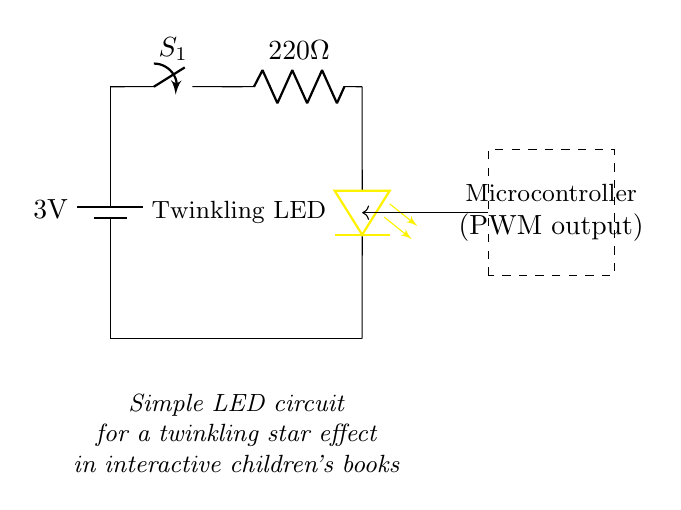What is the voltage of the battery? The voltage of the battery is labeled as 3 volts in the circuit diagram. This is a direct indication found in the schematic representation of the battery.
Answer: 3 volts What type of LED is used in the circuit? The LED is labeled as a "Twinkling LED" in the circuit diagram. This is specified alongside the LED symbol and indicates its function.
Answer: Twinkling LED What component controls the flow of current in this circuit? The switch labeled S1 controls the flow of current. When the switch is closed, current can flow through the circuit. This is evident from its placement in series with the battery and the rest of the components.
Answer: Switch Why is there a resistor in the circuit? The resistor, which is labeled as 220 ohms, is included to limit the current flowing through the LED. This prevents the LED from drawing too much current and being damaged. The value shows its role in controlling current in the circuit.
Answer: To limit current What is the function of the microcontroller in this circuit? The microcontroller is indicated to have a PWM output, which stands for Pulse Width Modulation. This allows the microcontroller to control the brightness of the LED by varying the power delivered to it over time, creating a twinkling effect. This functionality is stated in the dashed rectangle that represents the microcontroller in the diagram.
Answer: To control brightness 